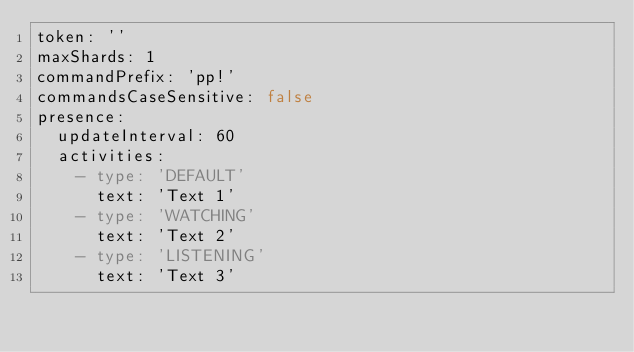<code> <loc_0><loc_0><loc_500><loc_500><_YAML_>token: ''
maxShards: 1
commandPrefix: 'pp!'
commandsCaseSensitive: false
presence:
  updateInterval: 60
  activities:
    - type: 'DEFAULT'
      text: 'Text 1'
    - type: 'WATCHING'
      text: 'Text 2'
    - type: 'LISTENING'
      text: 'Text 3'
</code> 